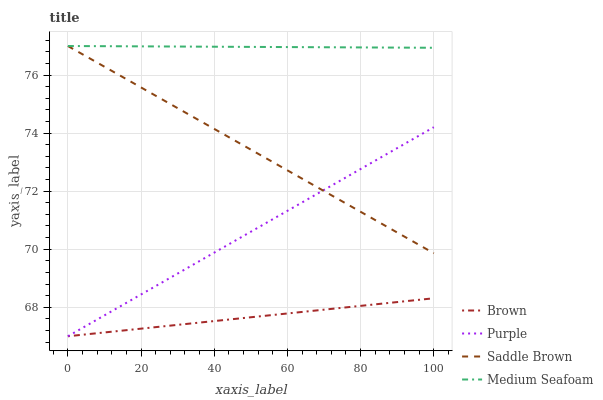Does Brown have the minimum area under the curve?
Answer yes or no. Yes. Does Medium Seafoam have the maximum area under the curve?
Answer yes or no. Yes. Does Saddle Brown have the minimum area under the curve?
Answer yes or no. No. Does Saddle Brown have the maximum area under the curve?
Answer yes or no. No. Is Purple the smoothest?
Answer yes or no. Yes. Is Saddle Brown the roughest?
Answer yes or no. Yes. Is Saddle Brown the smoothest?
Answer yes or no. No. Is Brown the roughest?
Answer yes or no. No. Does Purple have the lowest value?
Answer yes or no. Yes. Does Saddle Brown have the lowest value?
Answer yes or no. No. Does Medium Seafoam have the highest value?
Answer yes or no. Yes. Does Brown have the highest value?
Answer yes or no. No. Is Purple less than Medium Seafoam?
Answer yes or no. Yes. Is Medium Seafoam greater than Purple?
Answer yes or no. Yes. Does Medium Seafoam intersect Saddle Brown?
Answer yes or no. Yes. Is Medium Seafoam less than Saddle Brown?
Answer yes or no. No. Is Medium Seafoam greater than Saddle Brown?
Answer yes or no. No. Does Purple intersect Medium Seafoam?
Answer yes or no. No. 